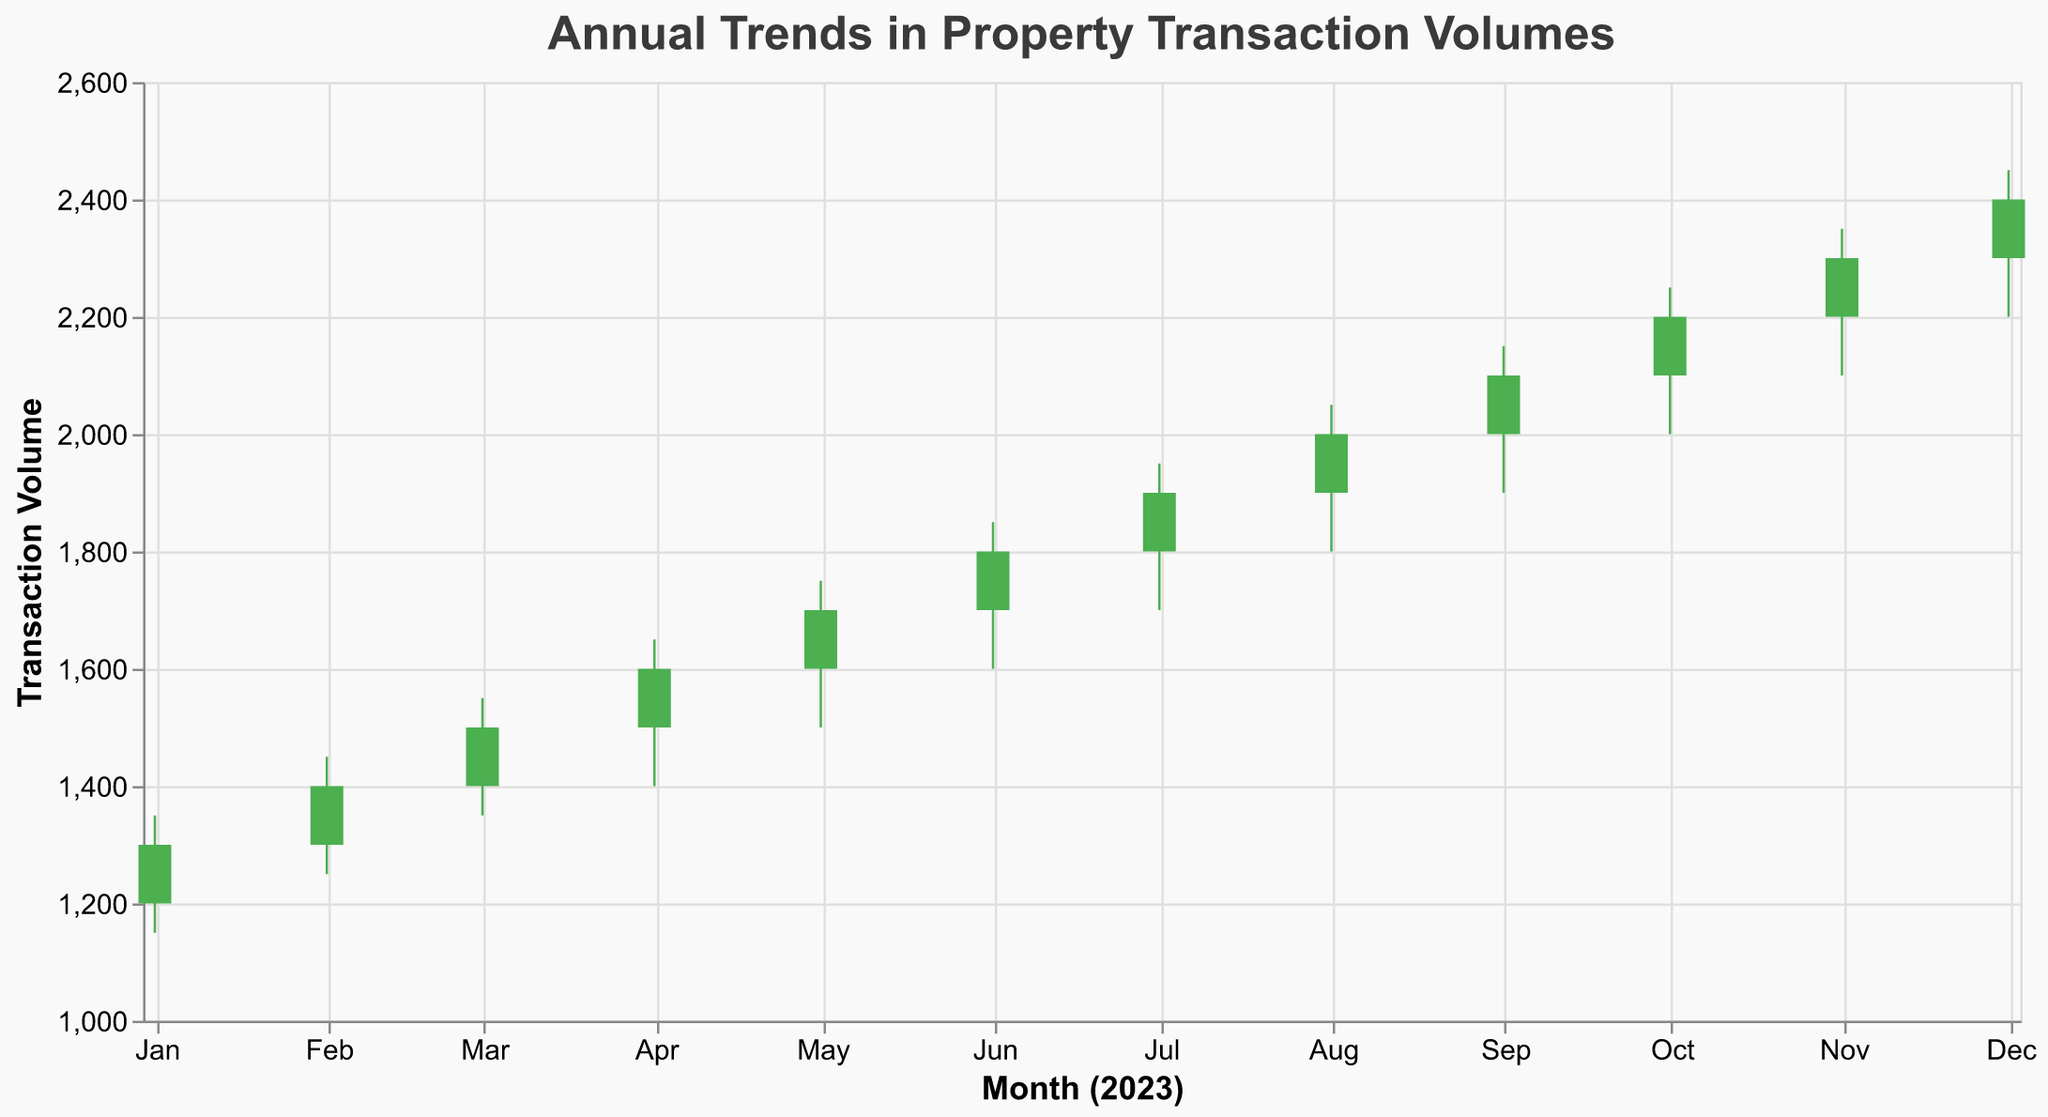What is the overall trend in the property transaction volumes from January to December? The trend can be observed through the increasing 'Close' values from January to December, starting at 1300 and ending at 2400. This indicates a continuous rise in transaction volumes over the year.
Answer: Increasing What is the 'Close' value for October? By locating the 'Close' label for October on the x-axis, you can find that the 'Close' value is 2200.
Answer: 2200 Which month has the highest transaction volume? By observing the vertical rules and comparing the 'High' labels, the highest transaction volume is in December, where the 'High' value is 2450.
Answer: December How does the transaction volume in May compare to that in June? Comparing the 'Close' values for May and June, May's 'Close' is 1700 while June's 'Close' is 1800. Therefore, June's volume is higher than May's.
Answer: June's volume is higher What is the largest increase in 'Close' values between two consecutive months? The largest increase can be determined by calculating the difference in 'Close' values for each pair of consecutive months: (1400 - 1300)=100, (1500 - 1400)=100, (1600 - 1500)=100, (1700 - 1600)=100, (1800 - 1700)=100, (1900 - 1800)=100, (2000 - 1900)=100, (2100 - 2000)=100, (2200 - 2100)=100, (2300 - 2200)=100, (2400 - 2300)=100. The largest increase is 100 across multiple pairs.
Answer: 100 How many months showed an increase in transaction volume compared to their previous month? By comparing 'Close' values month-by-month, all months from February to December show an increase compared to the previous month. This means an increase in 11 months.
Answer: 11 months What is the difference between the 'Low' value for March and the 'High' value for August? Subtract the 'Low' value for March (1350) from the 'High' value for August (2050): 2050 - 1350 = 700.
Answer: 700 In which months did the transaction volume decrease (red bars)? Red bars indicate a decrease in transaction volume when the 'Close' value is less than the 'Open' value. Observing the colors, there are no red bars, indicating no months with a decrease.
Answer: None Which month's high-to-low range (High - Low) is the largest and what is that range? Calculate the range for each month: (January: 200), (February: 200), (March: 200), (April: 250), (May: 250), (June: 250), (July: 250), (August: 250), (September: 250), (October: 250), (November: 250), (December: 250). Months from April to December all have the highest range of 250.
Answer: April-December, 250 